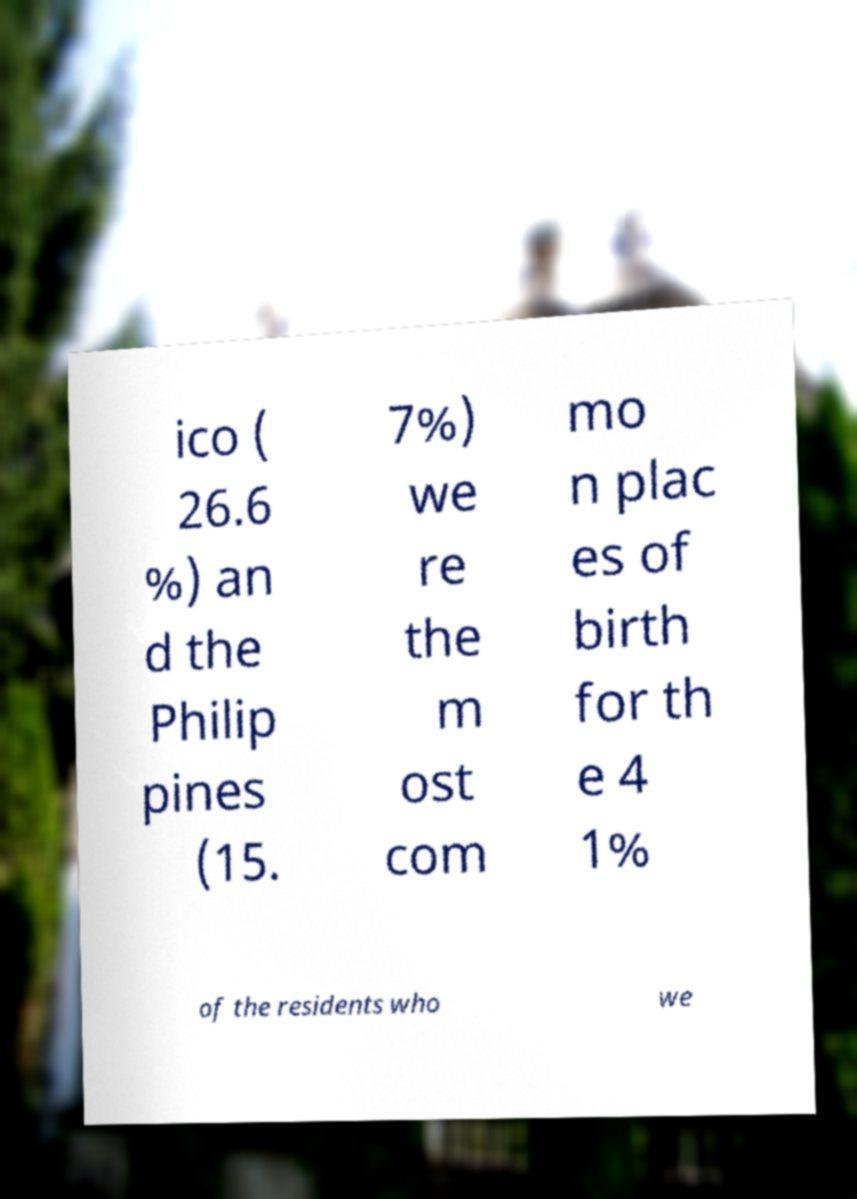Can you read and provide the text displayed in the image?This photo seems to have some interesting text. Can you extract and type it out for me? ico ( 26.6 %) an d the Philip pines (15. 7%) we re the m ost com mo n plac es of birth for th e 4 1% of the residents who we 